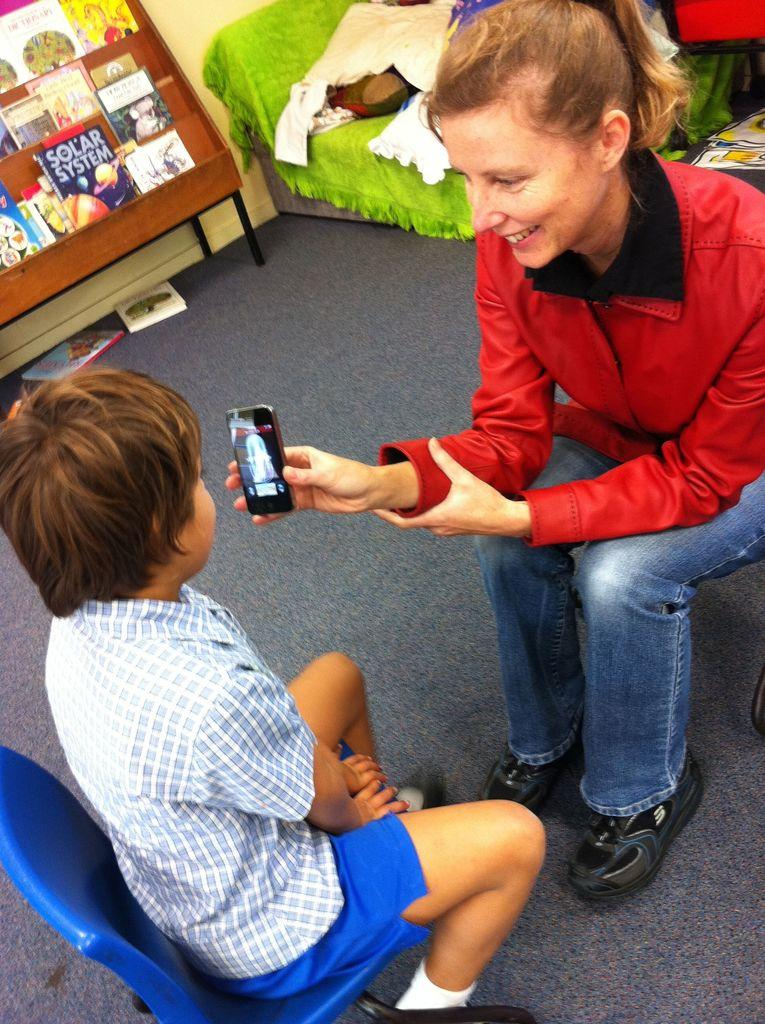<image>
Write a terse but informative summary of the picture. A display of books includes one that is titled Solar System. 